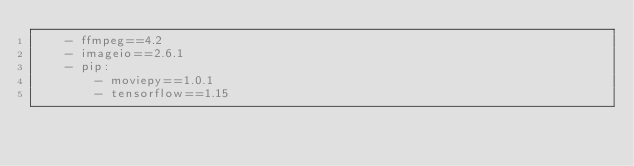<code> <loc_0><loc_0><loc_500><loc_500><_YAML_>    - ffmpeg==4.2
    - imageio==2.6.1
    - pip:
        - moviepy==1.0.1
        - tensorflow==1.15
</code> 